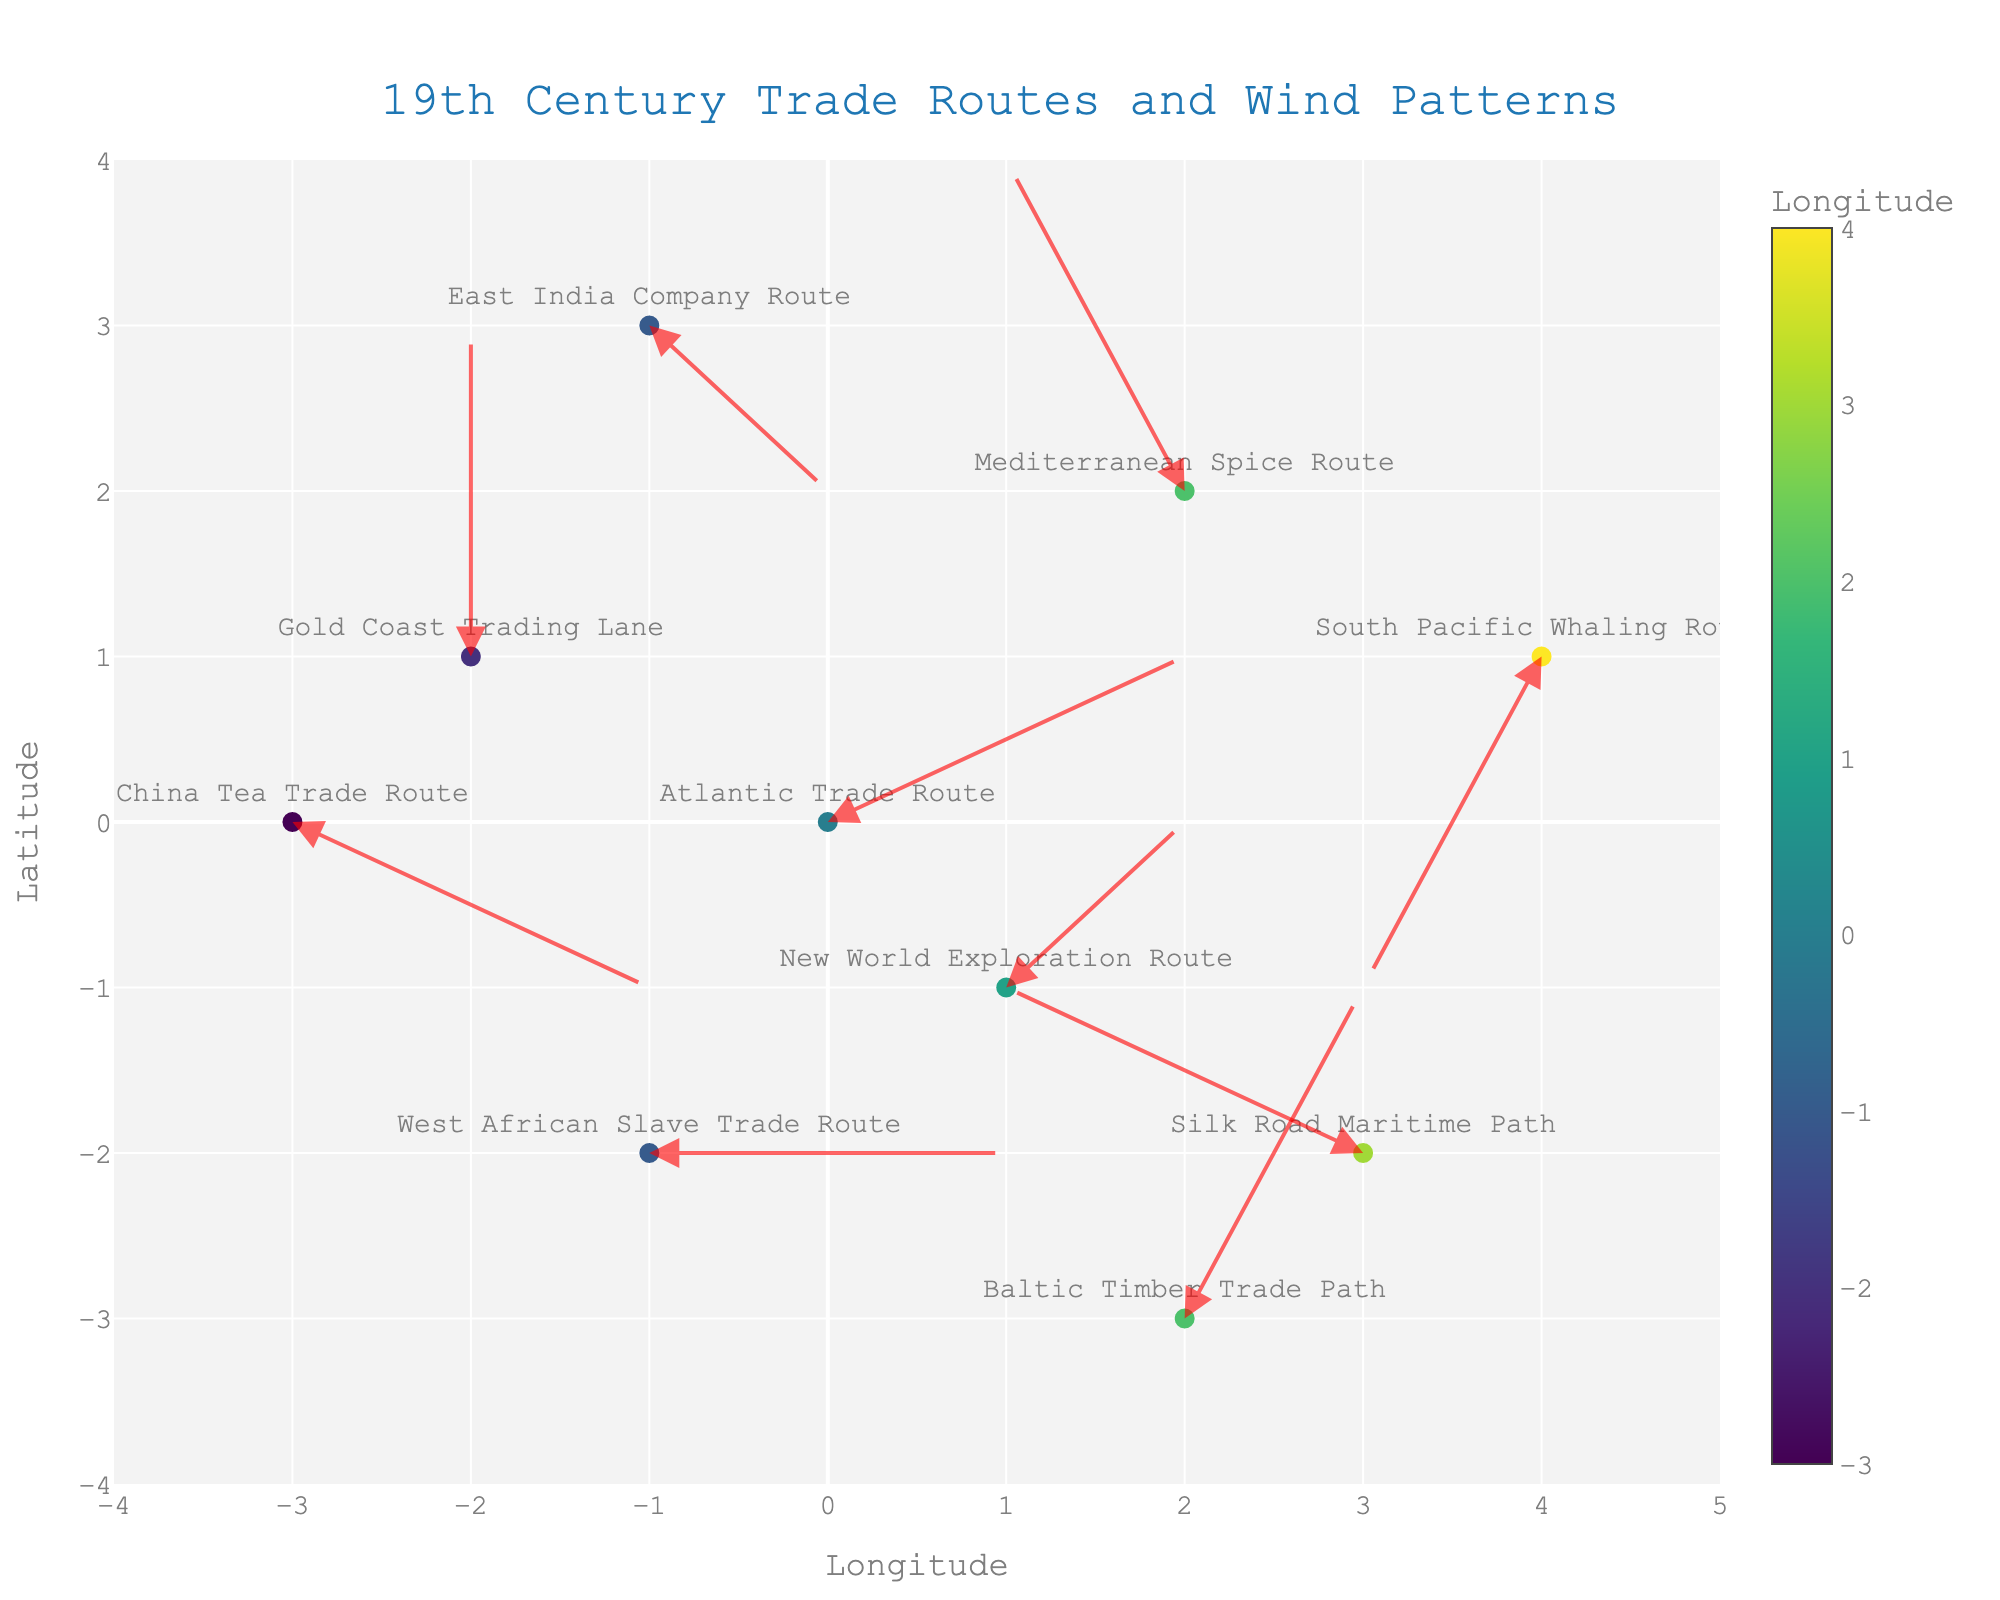how many trade routes are plotted? Count the number of points with route names.
Answer: 10 what is the title of the figure? Look at the main heading of the plot for the title.
Answer: 19th Century Trade Routes and Wind Patterns which trade route's wind direction moves from left to right? Locate the arrows pointing towards the right side; verify using coordinates and arrows.
Answer: West African Slave Trade Route what is the latitude range depicted in the plot? Find the y-axis range in the plot.
Answer: -4 to 4 which route name has the longest arrow? Measure the length of each arrow; compare distances.
Answer: Baltic Timber Trade Path which has a larger latitude value: the starting point of the Atlantic Trade Route or the Mediterranean Spice Route? Check the y-coordinates of both routes and compare them.
Answer: Mediterranean Spice Route which route has a horizontal wind pattern? Identify arrows completely horizontal using their u and v values.
Answer: West African Slave Trade Route which trade route starts at the lowest longitude? Find the point with the smallest x-coordinate.
Answer: China Tea Trade Route how far does the New World Exploration Route arrow move? Calculate the distance using u and v values with the formula √(u² + v²).
Answer: √(1² + 1²) ≈ 1.41 which two routes have wind patterns going north? Identify arrows pointing upwards (positive v values).
Answer: Mediterranean Spice Route, Gold Coast Trading Lane 